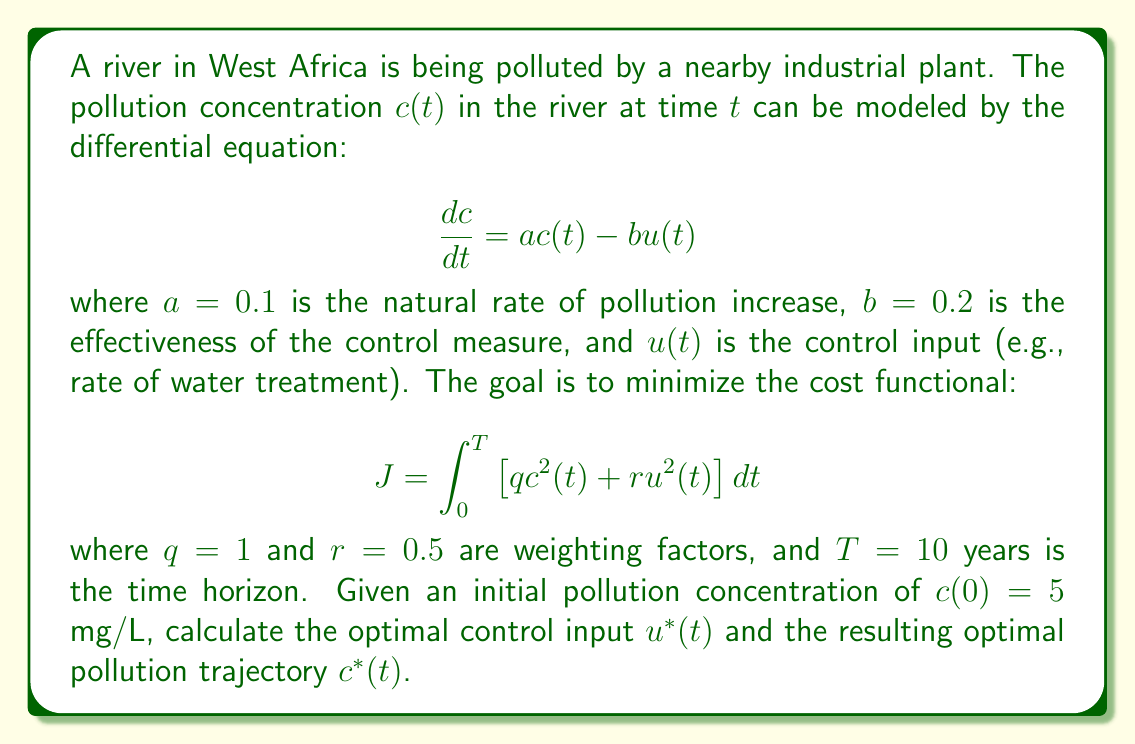Could you help me with this problem? To solve this optimal control problem, we can use the linear quadratic regulator (LQR) approach:

1. First, we identify the state equation:
   $$\frac{dc}{dt} = ac(t) - bu(t)$$
   where $a = 0.1$ and $b = 0.2$

2. The cost functional is in the quadratic form:
   $$J = \int_0^T \left[q c^2(t) + r u^2(t)\right] dt$$
   where $q = 1$, $r = 0.5$, and $T = 10$

3. For the infinite-horizon LQR problem, the optimal control is given by:
   $$u^*(t) = -Kc(t)$$
   where $K$ is the feedback gain

4. The feedback gain $K$ is calculated by solving the algebraic Riccati equation:
   $$aP + Pa - \frac{1}{r}Pb^2P + q = 0$$

5. Substituting the known values:
   $$0.1P + P(0.1) - \frac{1}{0.5}P(0.2)^2P + 1 = 0$$
   $$0.2P - 0.08P^2 + 1 = 0$$

6. Solving this quadratic equation:
   $$P = \frac{0.2 \pm \sqrt{0.04 + 4(0.08)(1)}}{2(0.08)} = \frac{0.2 \pm \sqrt{0.36}}{0.16} = \frac{0.2 \pm 0.6}{0.16}$$
   We take the positive root: $P = 5$

7. The feedback gain is then:
   $$K = \frac{1}{r}b P = \frac{1}{0.5}(0.2)(5) = 2$$

8. The optimal control input is:
   $$u^*(t) = -2c(t)$$

9. The optimal pollution trajectory can be found by solving the differential equation:
   $$\frac{dc}{dt} = ac(t) - bu^*(t) = 0.1c(t) - 0.2(-2c(t)) = 0.5c(t)$$
   With the initial condition $c(0) = 5$, the solution is:
   $$c^*(t) = 5e^{0.5t}$$
Answer: The optimal control input is $u^*(t) = -2c(t)$, and the optimal pollution trajectory is $c^*(t) = 5e^{0.5t}$ mg/L. 